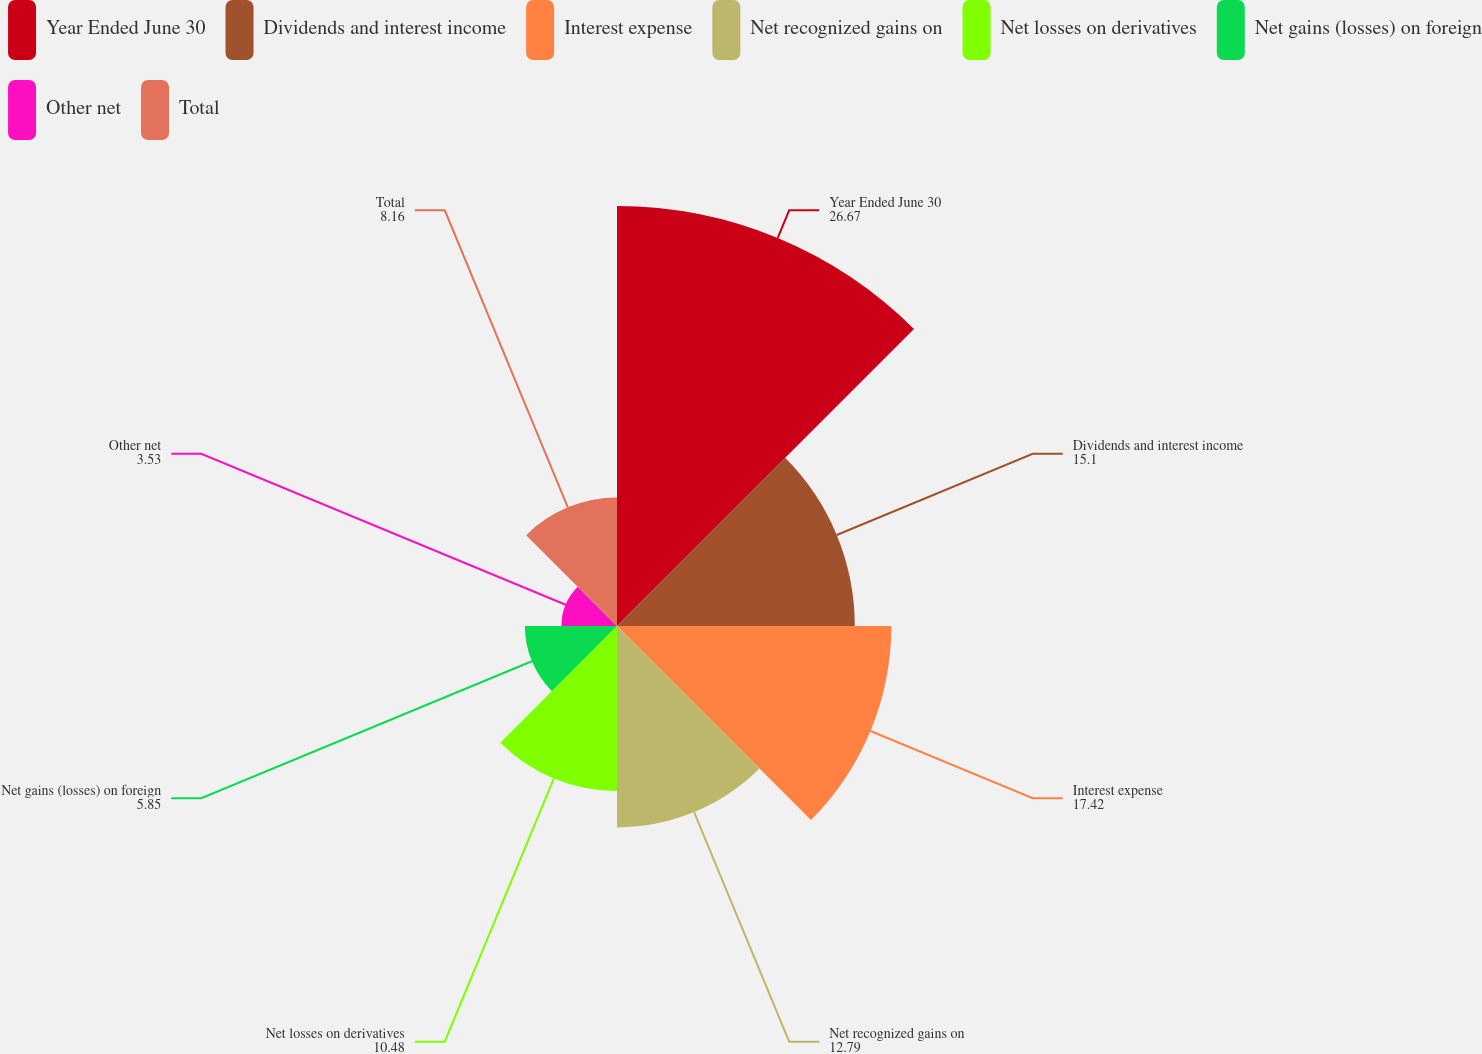Convert chart. <chart><loc_0><loc_0><loc_500><loc_500><pie_chart><fcel>Year Ended June 30<fcel>Dividends and interest income<fcel>Interest expense<fcel>Net recognized gains on<fcel>Net losses on derivatives<fcel>Net gains (losses) on foreign<fcel>Other net<fcel>Total<nl><fcel>26.67%<fcel>15.1%<fcel>17.42%<fcel>12.79%<fcel>10.48%<fcel>5.85%<fcel>3.53%<fcel>8.16%<nl></chart> 